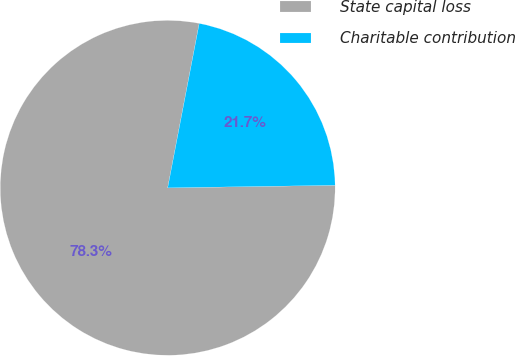<chart> <loc_0><loc_0><loc_500><loc_500><pie_chart><fcel>State capital loss<fcel>Charitable contribution<nl><fcel>78.26%<fcel>21.74%<nl></chart> 